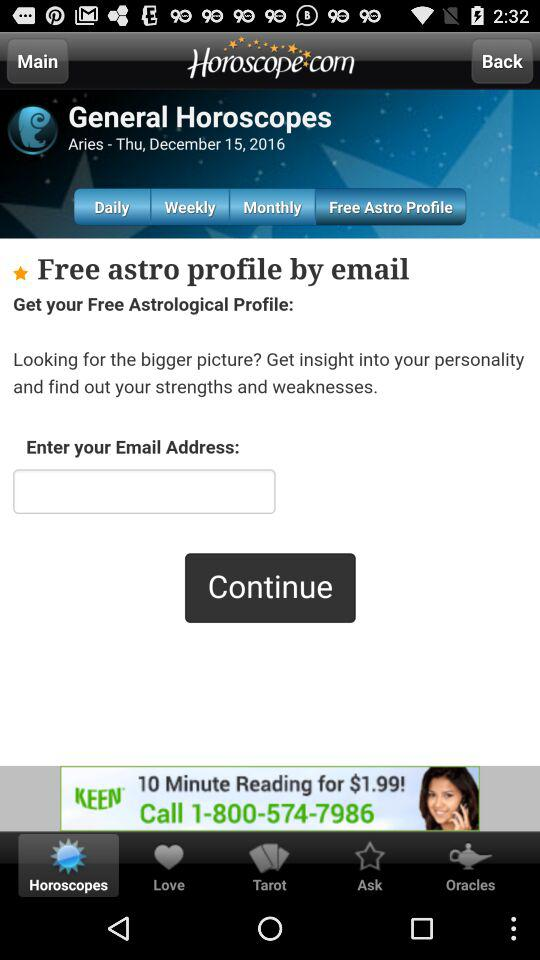What date is reflected on the screen? The date reflected on the screen is Thursday, December 15, 2016. 